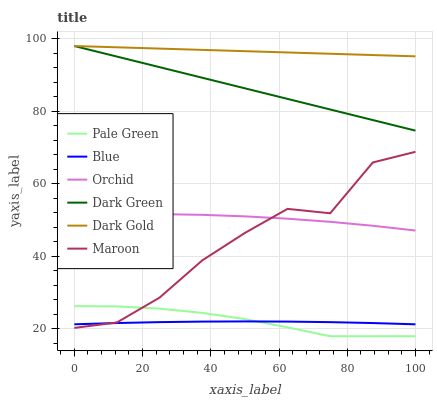Does Blue have the minimum area under the curve?
Answer yes or no. Yes. Does Dark Gold have the maximum area under the curve?
Answer yes or no. Yes. Does Maroon have the minimum area under the curve?
Answer yes or no. No. Does Maroon have the maximum area under the curve?
Answer yes or no. No. Is Dark Gold the smoothest?
Answer yes or no. Yes. Is Maroon the roughest?
Answer yes or no. Yes. Is Maroon the smoothest?
Answer yes or no. No. Is Dark Gold the roughest?
Answer yes or no. No. Does Maroon have the lowest value?
Answer yes or no. No. Does Maroon have the highest value?
Answer yes or no. No. Is Maroon less than Dark Green?
Answer yes or no. Yes. Is Dark Gold greater than Blue?
Answer yes or no. Yes. Does Maroon intersect Dark Green?
Answer yes or no. No. 